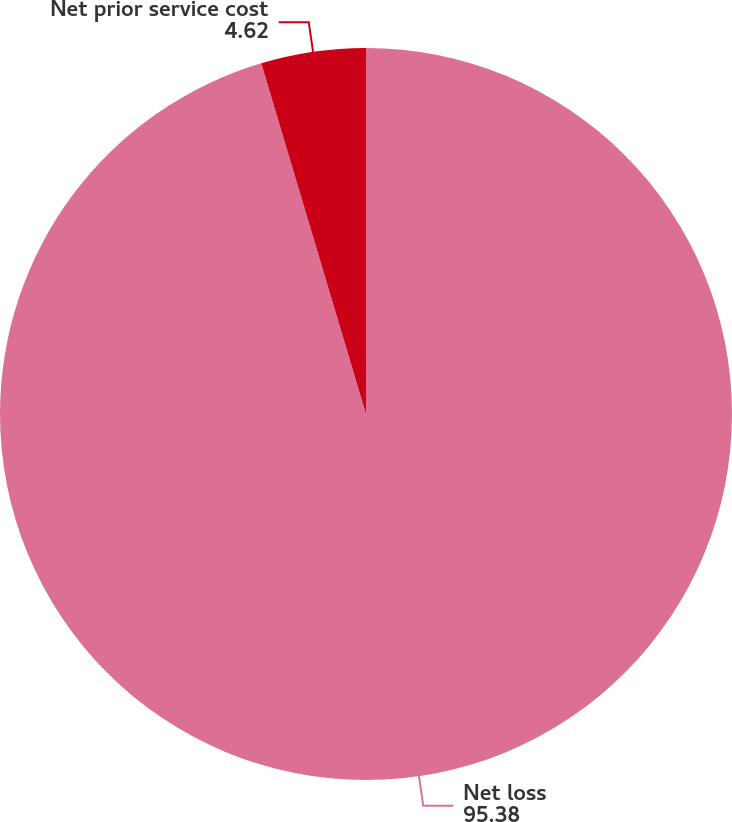Convert chart to OTSL. <chart><loc_0><loc_0><loc_500><loc_500><pie_chart><fcel>Net loss<fcel>Net prior service cost<nl><fcel>95.38%<fcel>4.62%<nl></chart> 